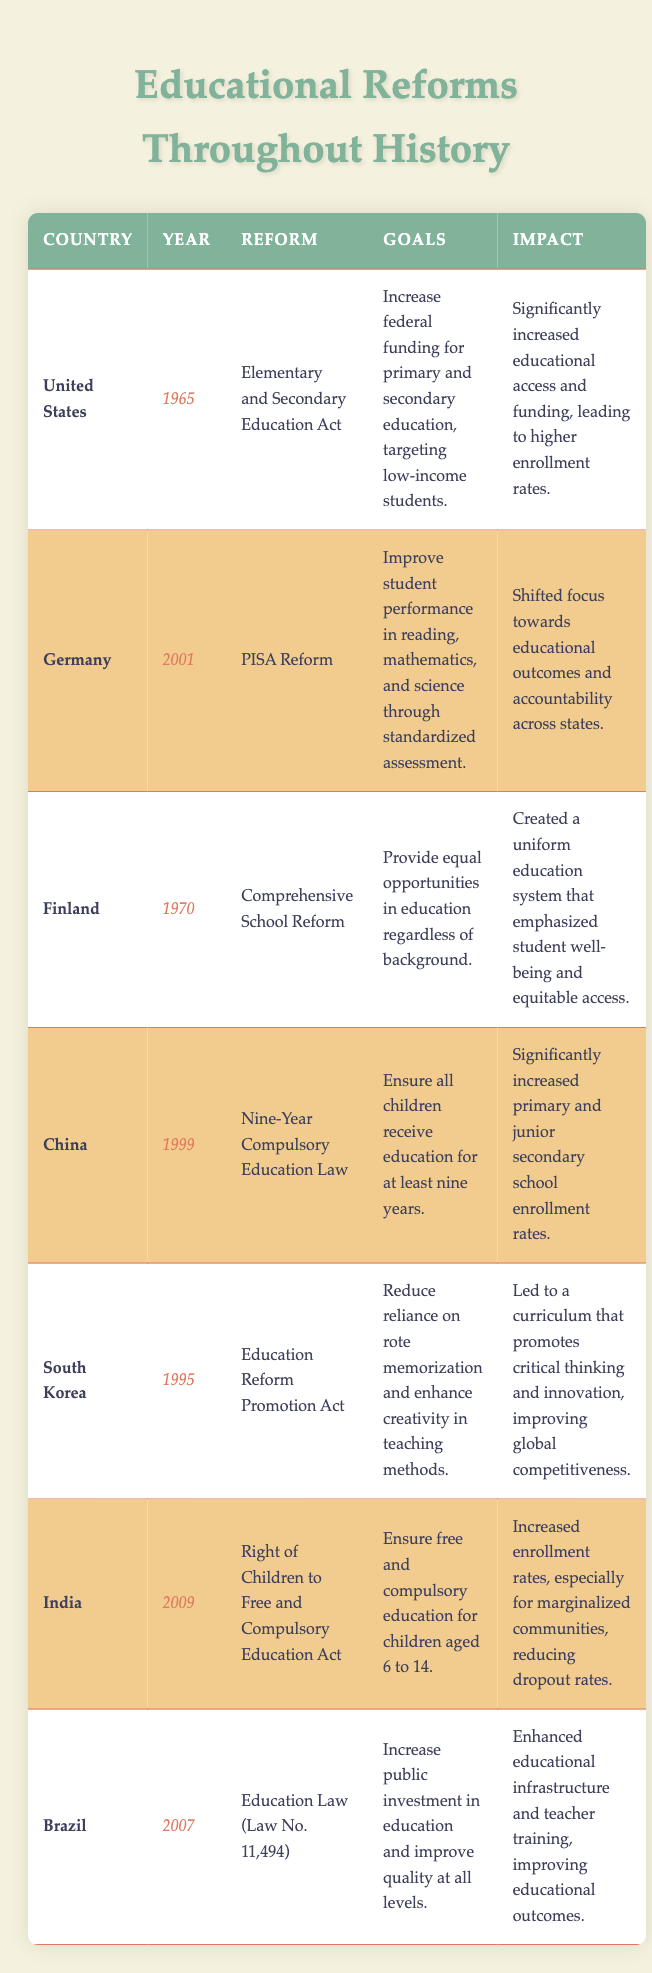What education reform was enacted in the United States in 1965? The table lists the reforms by year and country, where in 1965, the reform in the United States is identified as the "Elementary and Secondary Education Act."
Answer: Elementary and Secondary Education Act Which country implemented the Nine-Year Compulsory Education Law? Referring to the 'Reform' column in the table, the "Nine-Year Compulsory Education Law" is associated with China.
Answer: China How many years after the Nine-Year Compulsory Education Law was the Right of Children to Free and Compulsory Education Act enacted in India? The Nine-Year Compulsory Education Law was enacted in 1999 and the Right of Children to Free and Compulsory Education Act followed in 2009. The difference is 2009 - 1999 = 10 years.
Answer: 10 years Did the Education Reform Promotion Act in South Korea aim to reduce rote memorization? According to the 'Goals' column for South Korea, the Education Reform Promotion Act was specifically focused on reducing reliance on rote memorization. Hence, the statement is true.
Answer: Yes Which educational reform aimed at ensuring equity regardless of background, and which country implemented it? Referring to the table, the "Comprehensive School Reform" in Finland specifically aimed to provide equal opportunities, addressing equity in education.
Answer: Comprehensive School Reform, Finland What is the primary goal of the Education Law (Law No. 11,494) enacted in Brazil? The table outlines that the primary goal of Brazil's Education Law is to increase public investment in education and improve quality at all levels.
Answer: Increase public investment in education Which countries introduced educational reforms in the 1990s? By checking the 'Year' column, both South Korea (1995) and China (1999) introduced educational reforms in the 1990s, without other countries participating in the same decade.
Answer: South Korea, China What impact did the Comprehensive School Reform in Finland have? The 'Impact' column states that the Comprehensive School Reform created a uniform education system emphasizing student well-being and equitable access.
Answer: Created a uniform education system emphasizing student well-being What were the main educational outcomes targeted by the PISA Reform in Germany? The goals of the PISA Reform were to improve student performance in reading, mathematics, and science by implementing standardized assessment. This directly indicates the focus on educational outcomes.
Answer: Improve student performance in reading, mathematics, and science 